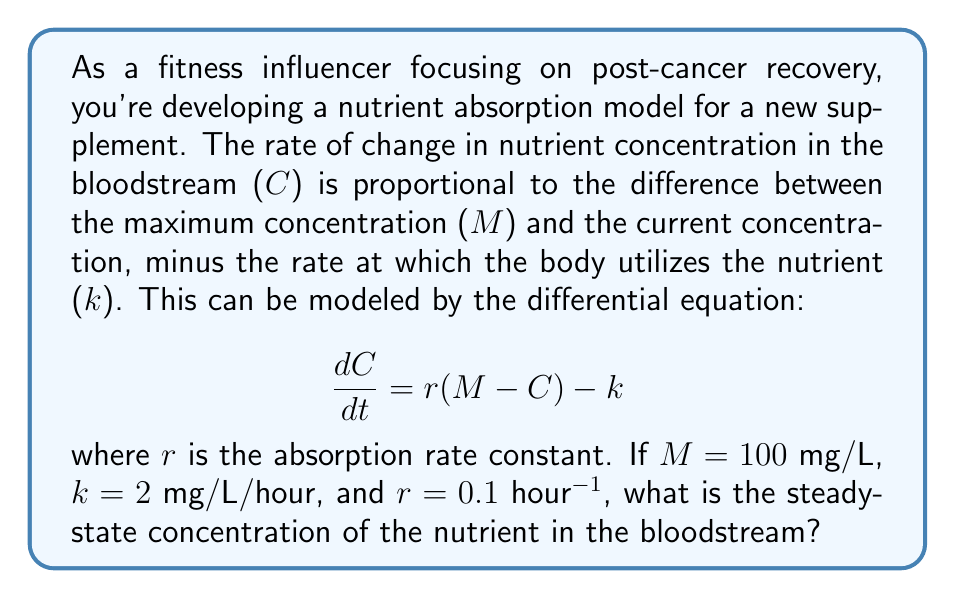Can you solve this math problem? To solve this problem, we need to find the steady-state concentration, which is the concentration at which the rate of change becomes zero. This occurs when the system reaches equilibrium.

1. Set the differential equation equal to zero:
   $$\frac{dC}{dt} = 0 = r(M - C) - k$$

2. Substitute the given values:
   $$0 = 0.1(100 - C) - 2$$

3. Solve for C:
   $$0 = 10 - 0.1C - 2$$
   $$0 = 8 - 0.1C$$
   $$0.1C = 8$$
   $$C = \frac{8}{0.1} = 80$$

Therefore, the steady-state concentration is 80 mg/L.

This result means that over time, the nutrient concentration in the bloodstream will approach and stabilize at 80 mg/L. At this concentration, the rate of absorption equals the rate of utilization, maintaining a constant level in the body.
Answer: The steady-state concentration of the nutrient in the bloodstream is 80 mg/L. 